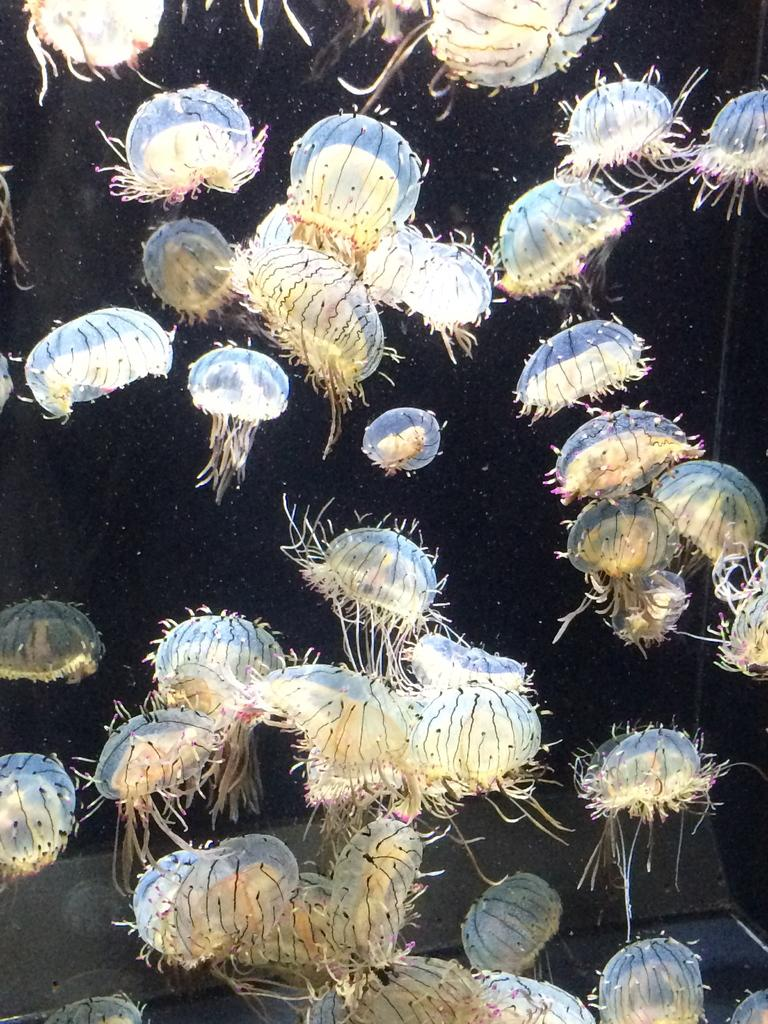What type of animals can be seen in the image? There are water animals in the image. What color is the background of the image? The background of the image is black. How many toes does the hen have in the image? There is no hen present in the image, so it is not possible to determine the number of toes it might have. 